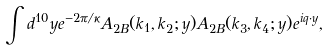<formula> <loc_0><loc_0><loc_500><loc_500>\int d ^ { 1 0 } y e ^ { - 2 \pi / \kappa } A _ { 2 B } ( k _ { 1 } , k _ { 2 } ; y ) A _ { 2 B } ( k _ { 3 } , k _ { 4 } ; y ) e ^ { i q \cdot y } ,</formula> 